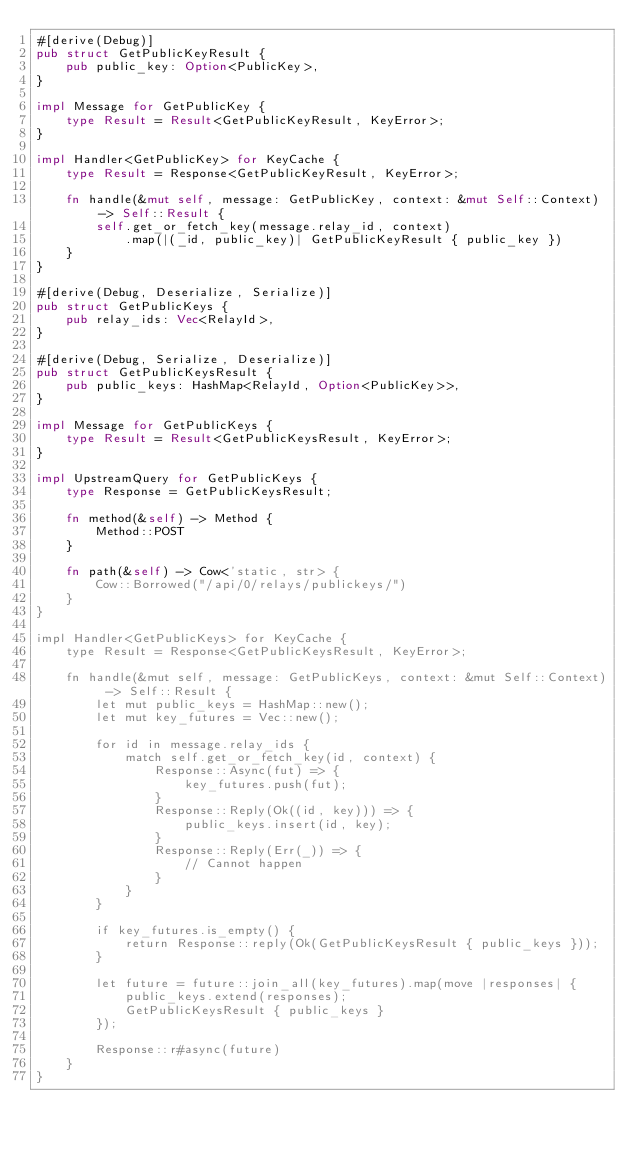<code> <loc_0><loc_0><loc_500><loc_500><_Rust_>#[derive(Debug)]
pub struct GetPublicKeyResult {
    pub public_key: Option<PublicKey>,
}

impl Message for GetPublicKey {
    type Result = Result<GetPublicKeyResult, KeyError>;
}

impl Handler<GetPublicKey> for KeyCache {
    type Result = Response<GetPublicKeyResult, KeyError>;

    fn handle(&mut self, message: GetPublicKey, context: &mut Self::Context) -> Self::Result {
        self.get_or_fetch_key(message.relay_id, context)
            .map(|(_id, public_key)| GetPublicKeyResult { public_key })
    }
}

#[derive(Debug, Deserialize, Serialize)]
pub struct GetPublicKeys {
    pub relay_ids: Vec<RelayId>,
}

#[derive(Debug, Serialize, Deserialize)]
pub struct GetPublicKeysResult {
    pub public_keys: HashMap<RelayId, Option<PublicKey>>,
}

impl Message for GetPublicKeys {
    type Result = Result<GetPublicKeysResult, KeyError>;
}

impl UpstreamQuery for GetPublicKeys {
    type Response = GetPublicKeysResult;

    fn method(&self) -> Method {
        Method::POST
    }

    fn path(&self) -> Cow<'static, str> {
        Cow::Borrowed("/api/0/relays/publickeys/")
    }
}

impl Handler<GetPublicKeys> for KeyCache {
    type Result = Response<GetPublicKeysResult, KeyError>;

    fn handle(&mut self, message: GetPublicKeys, context: &mut Self::Context) -> Self::Result {
        let mut public_keys = HashMap::new();
        let mut key_futures = Vec::new();

        for id in message.relay_ids {
            match self.get_or_fetch_key(id, context) {
                Response::Async(fut) => {
                    key_futures.push(fut);
                }
                Response::Reply(Ok((id, key))) => {
                    public_keys.insert(id, key);
                }
                Response::Reply(Err(_)) => {
                    // Cannot happen
                }
            }
        }

        if key_futures.is_empty() {
            return Response::reply(Ok(GetPublicKeysResult { public_keys }));
        }

        let future = future::join_all(key_futures).map(move |responses| {
            public_keys.extend(responses);
            GetPublicKeysResult { public_keys }
        });

        Response::r#async(future)
    }
}
</code> 